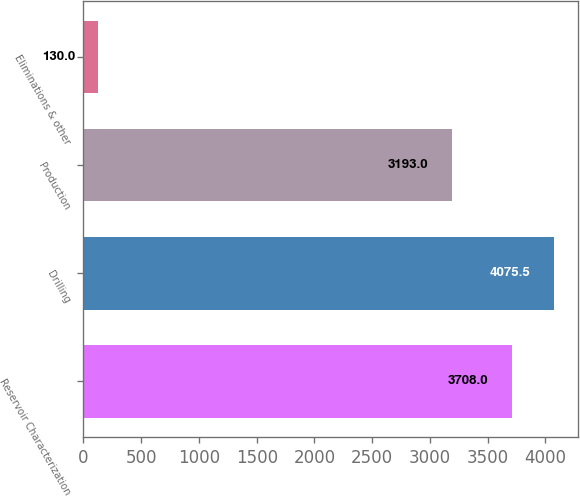Convert chart. <chart><loc_0><loc_0><loc_500><loc_500><bar_chart><fcel>Reservoir Characterization<fcel>Drilling<fcel>Production<fcel>Eliminations & other<nl><fcel>3708<fcel>4075.5<fcel>3193<fcel>130<nl></chart> 